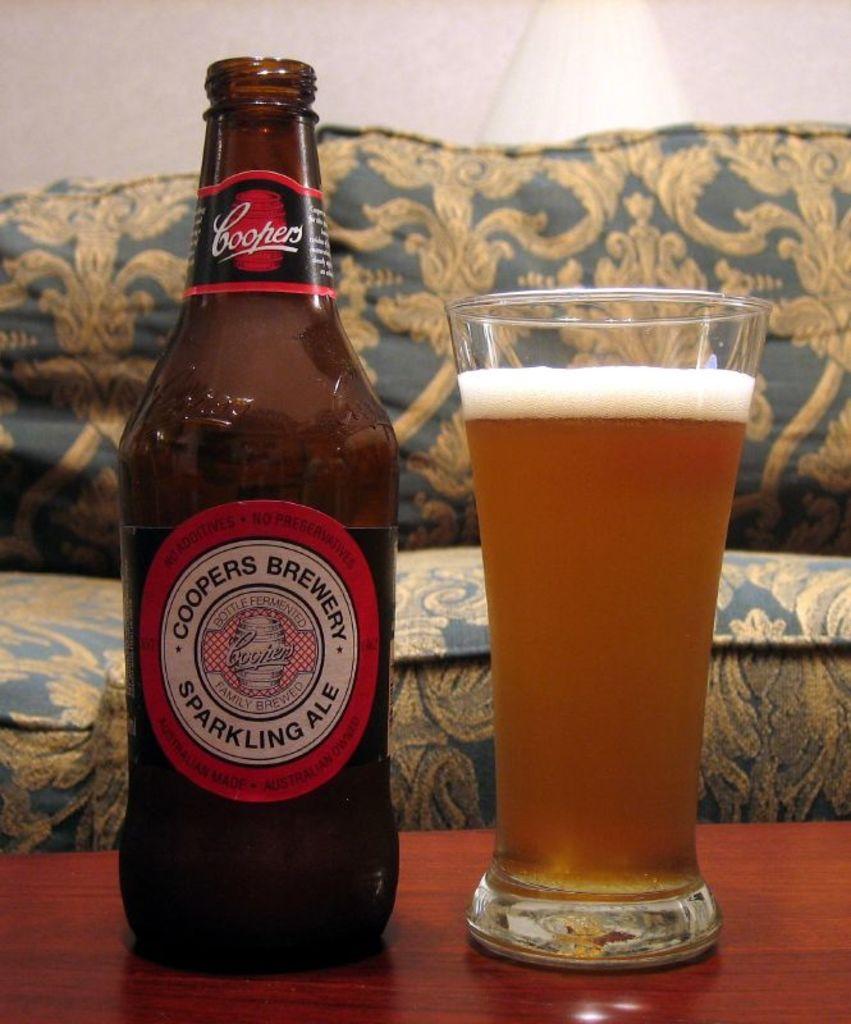Which brewery made this ale?
Offer a very short reply. Coopers. What brewery is this beer from?
Provide a succinct answer. Coopers. 